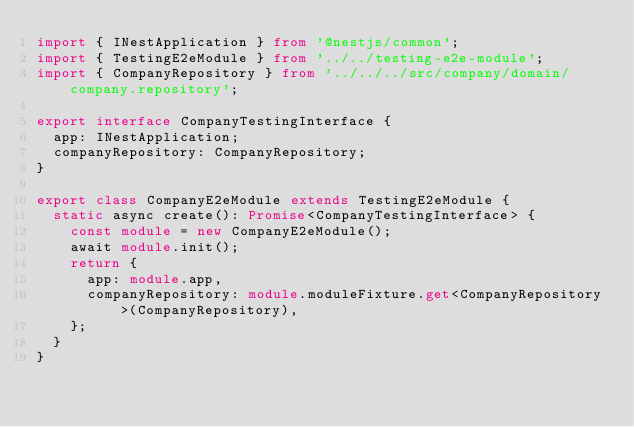<code> <loc_0><loc_0><loc_500><loc_500><_TypeScript_>import { INestApplication } from '@nestjs/common';
import { TestingE2eModule } from '../../testing-e2e-module';
import { CompanyRepository } from '../../../src/company/domain/company.repository';

export interface CompanyTestingInterface {
  app: INestApplication;
  companyRepository: CompanyRepository;
}

export class CompanyE2eModule extends TestingE2eModule {
  static async create(): Promise<CompanyTestingInterface> {
    const module = new CompanyE2eModule();
    await module.init();
    return {
      app: module.app,
      companyRepository: module.moduleFixture.get<CompanyRepository>(CompanyRepository),
    };
  }
}
</code> 